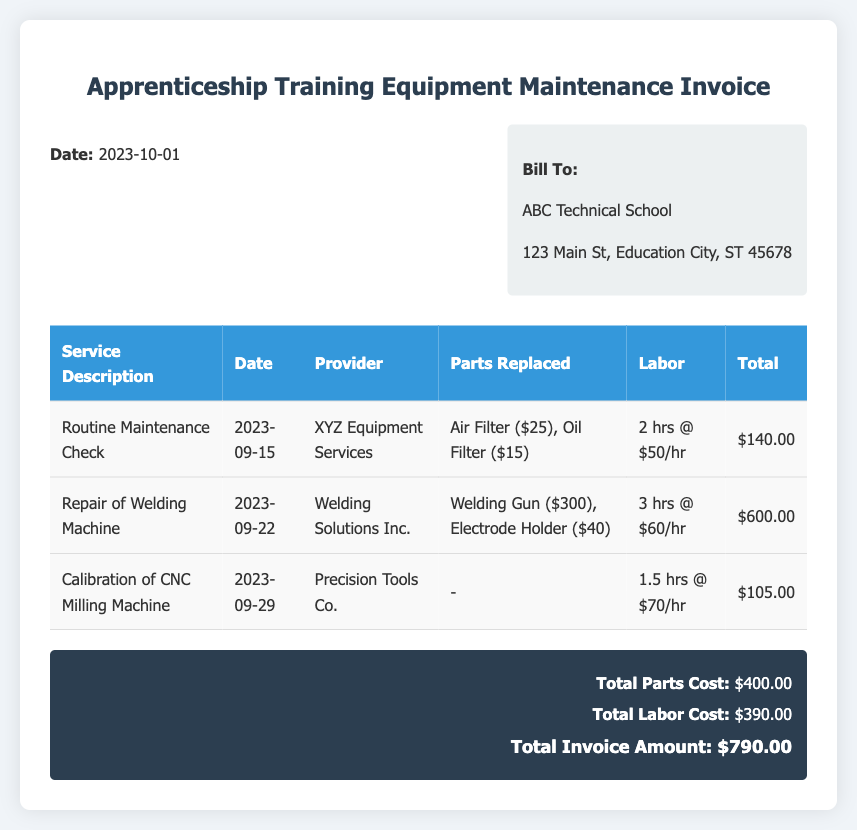What is the date of the invoice? The date of the invoice is stated at the top of the document.
Answer: 2023-10-01 Who is the bill addressed to? The document specifies the recipient of the bill in the billing section.
Answer: ABC Technical School What is the total parts cost? The total parts cost is summarized in the summary section of the document.
Answer: $400.00 How many hours were billed for labor on the repair of the welding machine? The labor time for the welding machine repair is mentioned in the service item details.
Answer: 3 hrs What is the total invoice amount? The total invoice amount is the final summary figure at the bottom of the document.
Answer: $790.00 Which provider serviced the CNC Milling Machine? The provider for the CNC Milling Machine is listed in the table under the provider column.
Answer: Precision Tools Co What was replaced during the routine maintenance check? The details of the parts replaced are listed under the Routine Maintenance Check service item.
Answer: Air Filter, Oil Filter Which service had the highest total cost? The total costs for each service can be compared to determine which is highest.
Answer: Repair of Welding Machine What type of service was performed on September 29? The type of service is mentioned in the description for that date.
Answer: Calibration of CNC Milling Machine 